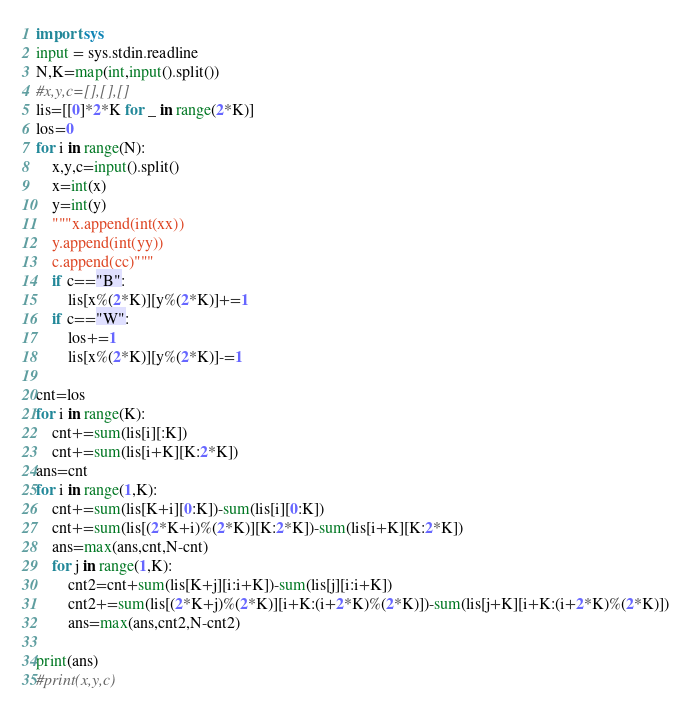Convert code to text. <code><loc_0><loc_0><loc_500><loc_500><_Python_>import sys
input = sys.stdin.readline
N,K=map(int,input().split())
#x,y,c=[],[],[]
lis=[[0]*2*K for _ in range(2*K)]
los=0
for i in range(N):
    x,y,c=input().split()
    x=int(x)
    y=int(y)
    """x.append(int(xx))
    y.append(int(yy))
    c.append(cc)"""
    if c=="B":
        lis[x%(2*K)][y%(2*K)]+=1
    if c=="W":
        los+=1
        lis[x%(2*K)][y%(2*K)]-=1

cnt=los
for i in range(K):
    cnt+=sum(lis[i][:K])
    cnt+=sum(lis[i+K][K:2*K])
ans=cnt
for i in range(1,K):
    cnt+=sum(lis[K+i][0:K])-sum(lis[i][0:K])
    cnt+=sum(lis[(2*K+i)%(2*K)][K:2*K])-sum(lis[i+K][K:2*K])
    ans=max(ans,cnt,N-cnt)
    for j in range(1,K):
        cnt2=cnt+sum(lis[K+j][i:i+K])-sum(lis[j][i:i+K])
        cnt2+=sum(lis[(2*K+j)%(2*K)][i+K:(i+2*K)%(2*K)])-sum(lis[j+K][i+K:(i+2*K)%(2*K)])
        ans=max(ans,cnt2,N-cnt2)

print(ans)
#print(x,y,c)
</code> 